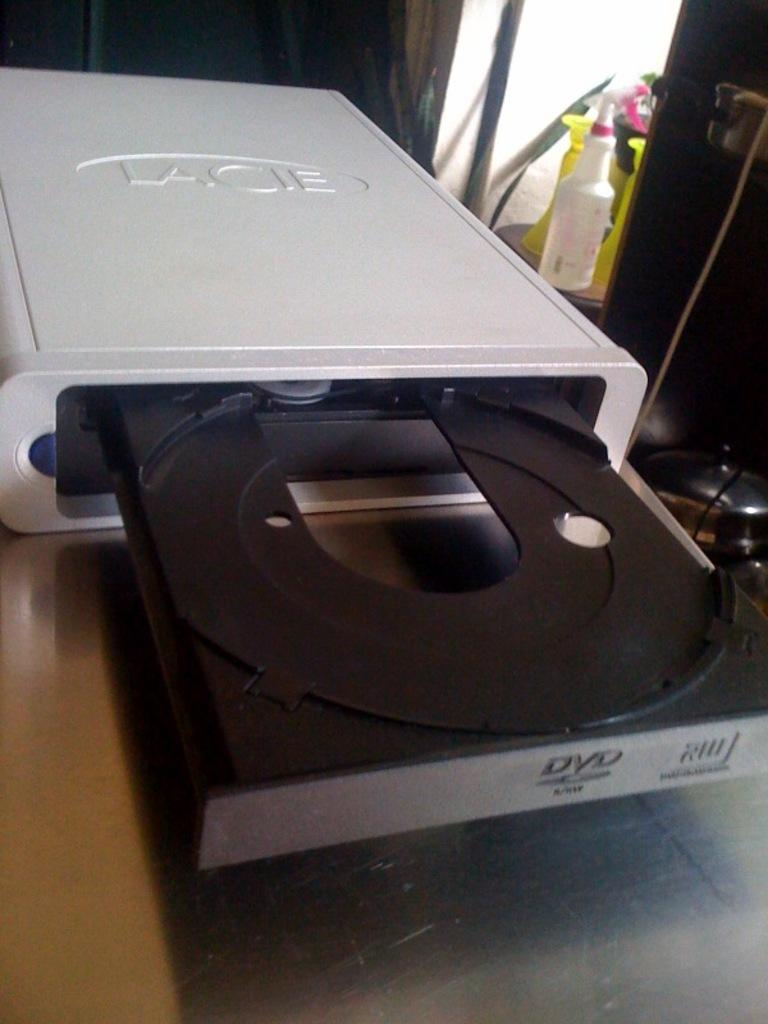<image>
Summarize the visual content of the image. A Lacie disk drive that is open without a Cd. 